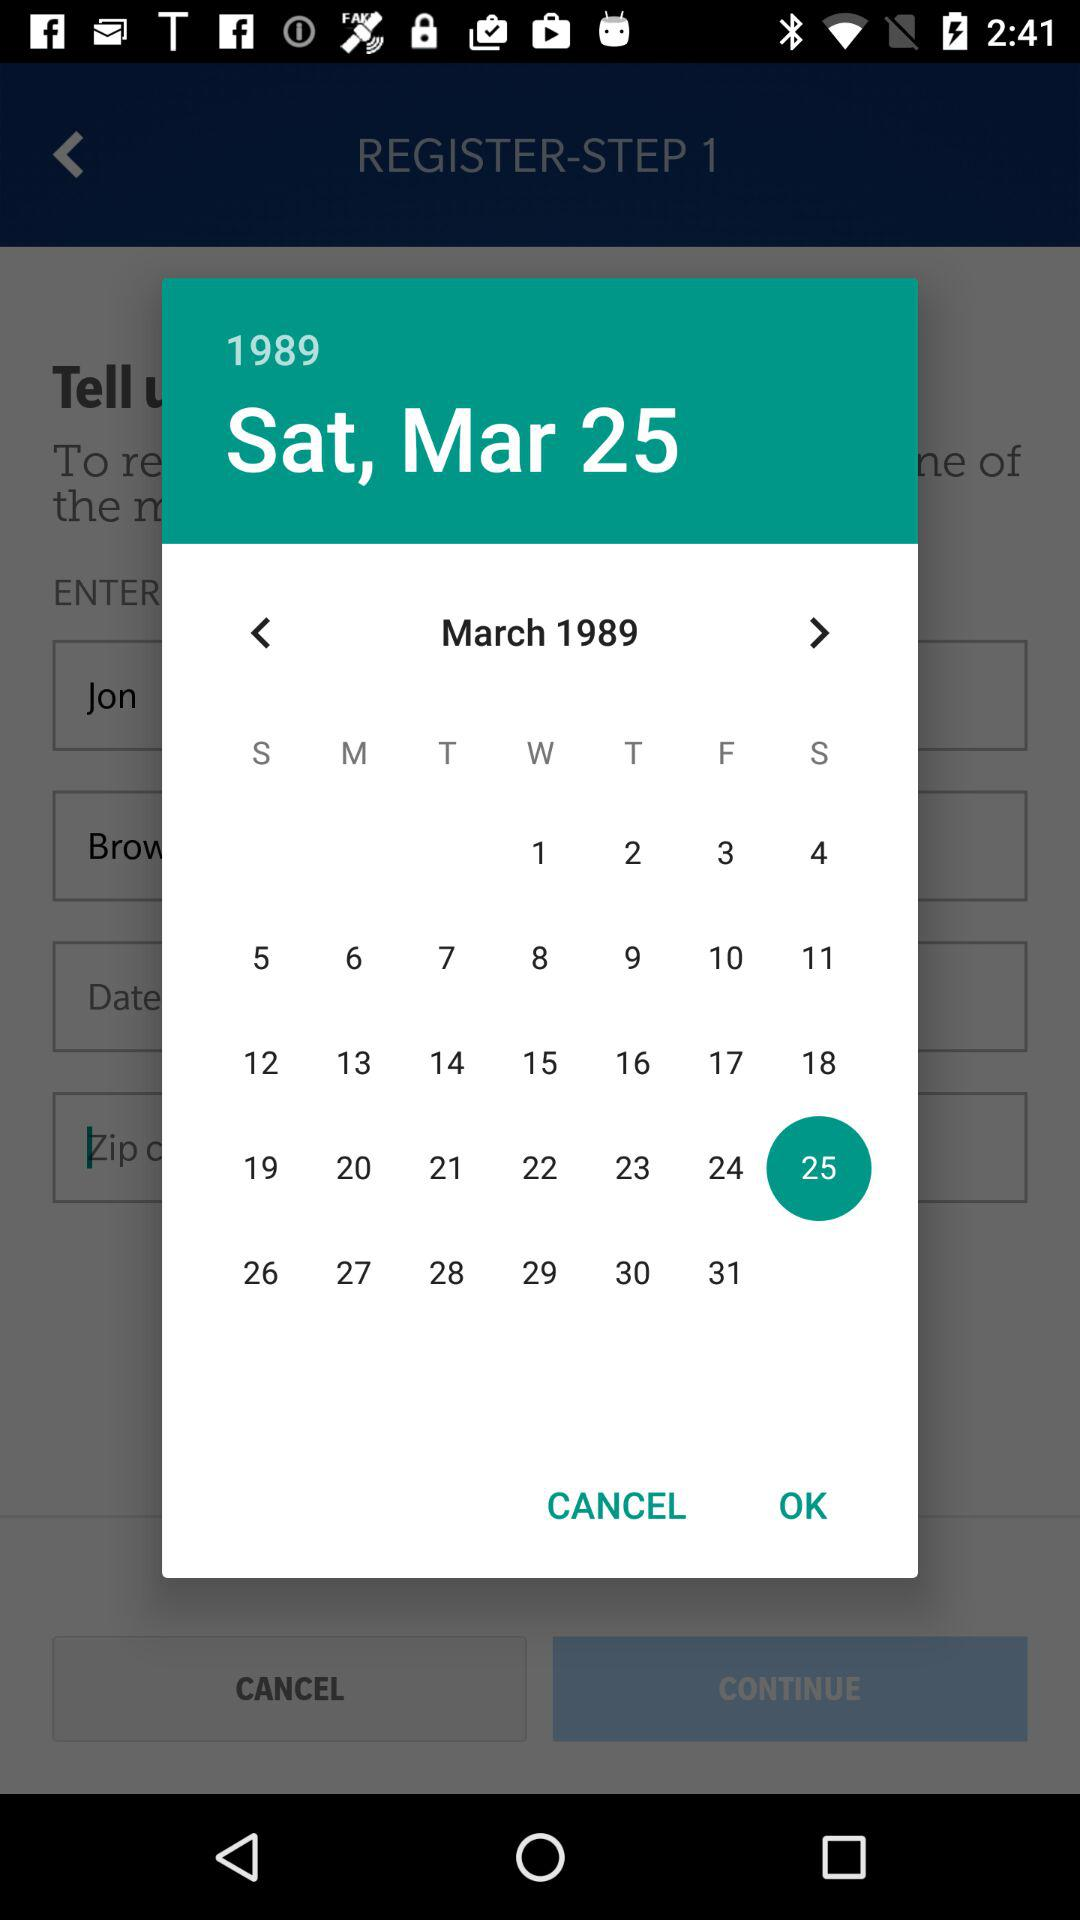What is the year? The year is 1989. 